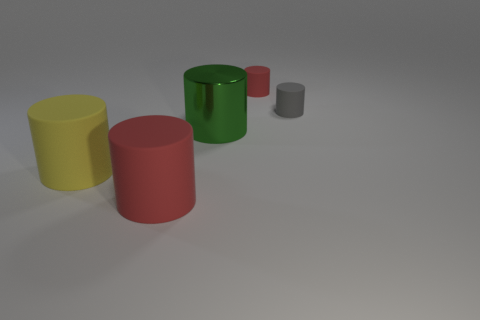What is the color of the matte cylinder that is to the left of the gray cylinder and on the right side of the big red cylinder?
Offer a very short reply. Red. There is a red rubber object behind the gray rubber cylinder; is it the same size as the tiny gray matte cylinder?
Ensure brevity in your answer.  Yes. Are there any other things that have the same shape as the gray thing?
Provide a succinct answer. Yes. Are the large green thing and the red object in front of the tiny red matte cylinder made of the same material?
Make the answer very short. No. What number of yellow things are tiny spheres or large things?
Make the answer very short. 1. Are there any big red metallic spheres?
Provide a short and direct response. No. There is a small rubber object that is in front of the red rubber cylinder behind the big green object; are there any large yellow matte cylinders behind it?
Give a very brief answer. No. Is there anything else that is the same size as the yellow object?
Keep it short and to the point. Yes. There is a tiny gray thing; does it have the same shape as the red thing behind the gray thing?
Offer a very short reply. Yes. The cylinder that is in front of the big matte object behind the red matte cylinder that is left of the big green shiny cylinder is what color?
Give a very brief answer. Red. 